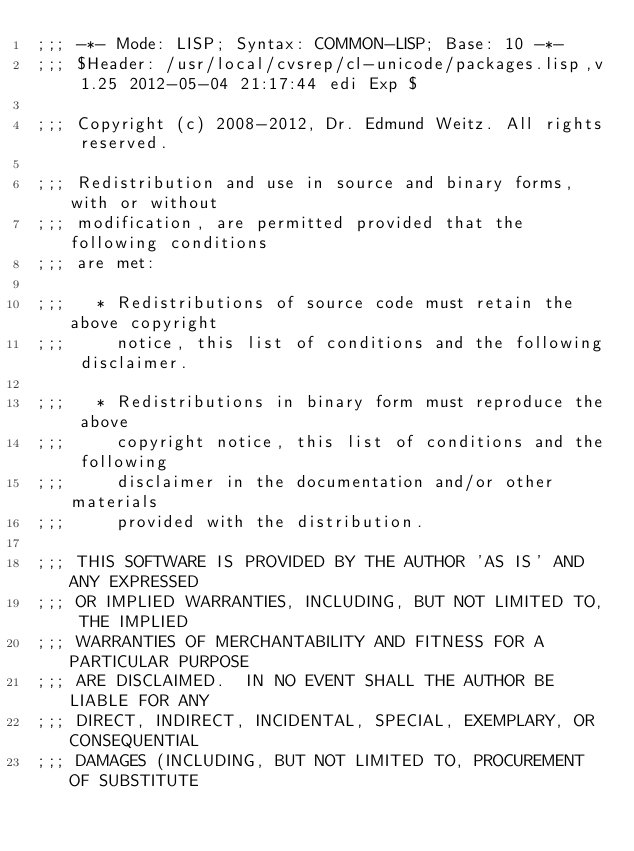<code> <loc_0><loc_0><loc_500><loc_500><_Lisp_>;;; -*- Mode: LISP; Syntax: COMMON-LISP; Base: 10 -*-
;;; $Header: /usr/local/cvsrep/cl-unicode/packages.lisp,v 1.25 2012-05-04 21:17:44 edi Exp $

;;; Copyright (c) 2008-2012, Dr. Edmund Weitz. All rights reserved.

;;; Redistribution and use in source and binary forms, with or without
;;; modification, are permitted provided that the following conditions
;;; are met:

;;;   * Redistributions of source code must retain the above copyright
;;;     notice, this list of conditions and the following disclaimer.

;;;   * Redistributions in binary form must reproduce the above
;;;     copyright notice, this list of conditions and the following
;;;     disclaimer in the documentation and/or other materials
;;;     provided with the distribution.

;;; THIS SOFTWARE IS PROVIDED BY THE AUTHOR 'AS IS' AND ANY EXPRESSED
;;; OR IMPLIED WARRANTIES, INCLUDING, BUT NOT LIMITED TO, THE IMPLIED
;;; WARRANTIES OF MERCHANTABILITY AND FITNESS FOR A PARTICULAR PURPOSE
;;; ARE DISCLAIMED.  IN NO EVENT SHALL THE AUTHOR BE LIABLE FOR ANY
;;; DIRECT, INDIRECT, INCIDENTAL, SPECIAL, EXEMPLARY, OR CONSEQUENTIAL
;;; DAMAGES (INCLUDING, BUT NOT LIMITED TO, PROCUREMENT OF SUBSTITUTE</code> 